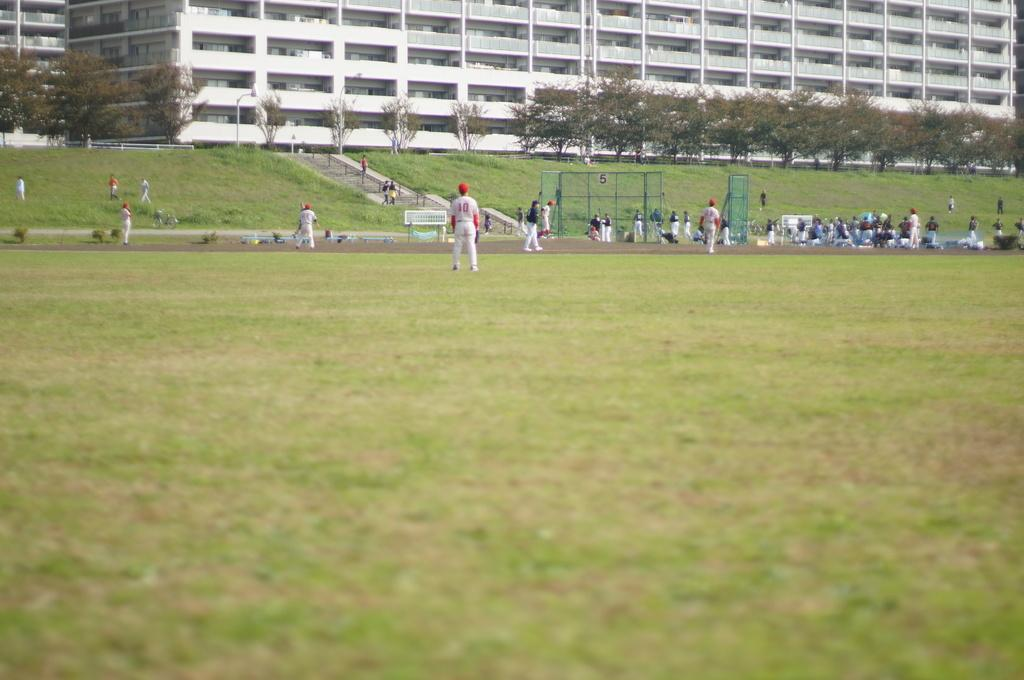What is the primary surface visible in the image? There is a ground in the image. What is happening on the ground? There are people on the ground. What object is present in the image that is typically used for separating or dividing areas? There is a net in the image. What type of structure can be seen in the image? There is a building in the image. What type of natural elements are present in the image? There are trees and plants in the image. What type of credit card is being used by the people in the image? There is no credit card visible in the image; it only shows people on the ground, a net, a building, trees, and plants. Can you tell me how many giraffes are present in the image? There are no giraffes present in the image. 